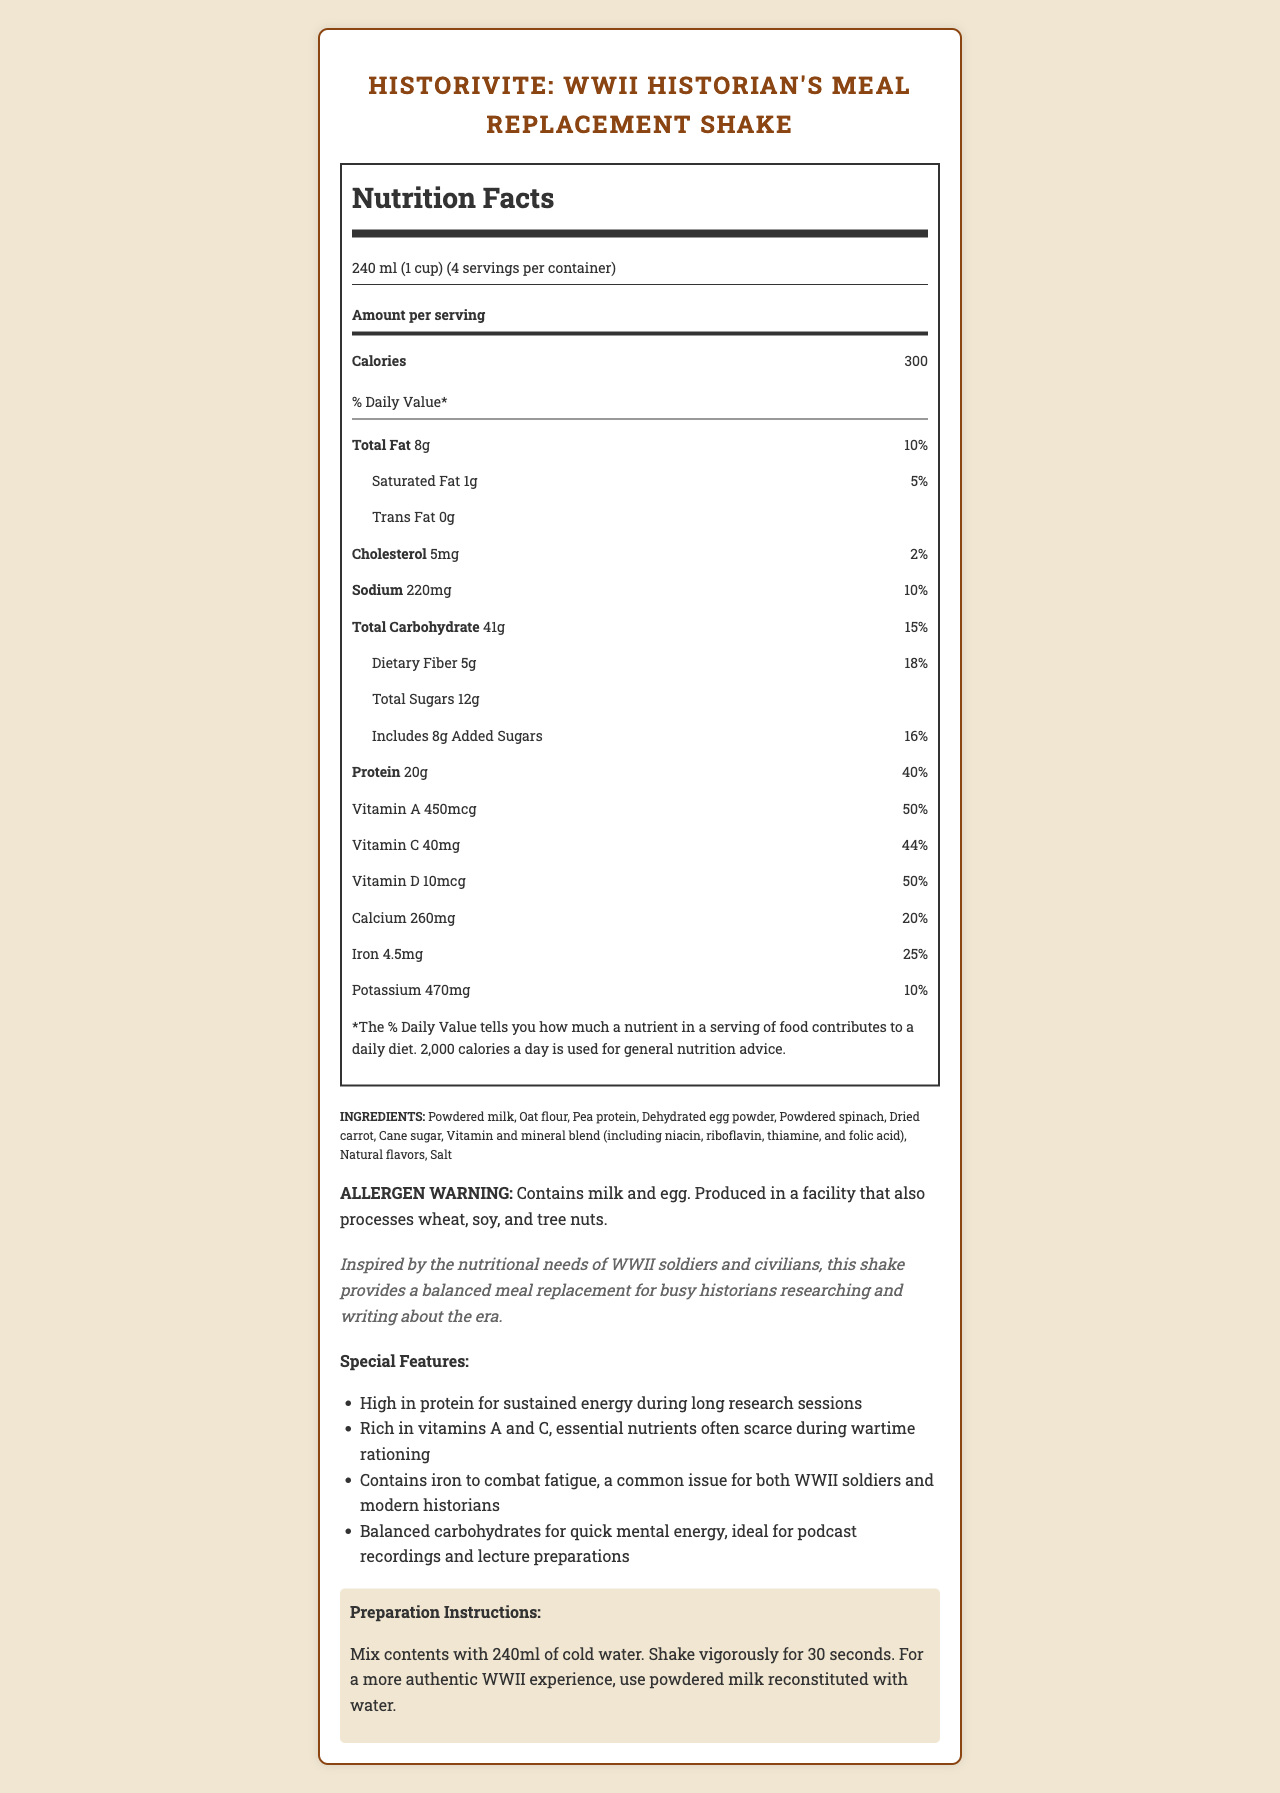what is the serving size of the meal replacement shake? The serving size is explicitly mentioned under the nutrition facts as "240 ml (1 cup)."
Answer: 240 ml (1 cup) how many calories are in one serving of HistoriVite? The document specifies that each serving contains 300 calories.
Answer: 300 list three ingredients found in HistoriVite? The ingredients list includes powdered milk, oat flour, and pea protein among others.
Answer: Powdered milk, Oat flour, Pea protein how many grams of dietary fiber are in each serving? The nutrition facts label states that there are 5 grams of dietary fiber per serving.
Answer: 5g what is the percent daily value of protein in one serving? The percent daily value of protein is indicated as 40% in the nutrition facts.
Answer: 40% how many servings are in one container of HistoriVite? The document specifies that there are 4 servings per container.
Answer: 4 how much sodium is in a serving of the shake? A. 100mg B. 150mg C. 220mg D. 300mg According to the nutrition facts, each serving contains 220 mg of sodium.
Answer: C which of the following vitamins is present in the highest percent daily value? A. Vitamin A B. Vitamin C C. Vitamin D D. Calcium Vitamin A has a percent daily value of 50%, which is the highest among the listed options.
Answer: A does the HistoriVite shake contain any trans fat? The nutrition facts clearly indicate that the shake contains 0g of trans fat.
Answer: No is HistoriVite suitable for individuals with egg allergies? The allergen warning specifies that the product contains egg.
Answer: No summarize the main purpose of the HistoriVite meal replacement shake. The shake aims to support historians by offering a convenient and nutritionally balanced option that mirrors the dietary needs of WWII-era individuals, but tailored for modern historians' hectic schedules.
Answer: The HistoriVite shake is designed as a balanced meal replacement for busy historians, inspired by the nutritional needs of WWII soldiers and civilians. It provides high protein for energy, essential vitamins, and iron to combat fatigue, making it ideal for long research sessions and lecture preparations. why was HistoriVite inspired by the nutritional needs of WWII soldiers and civilians? The historical context section states that the shake is inspired by the nutritional needs of WWII soldiers and civilians to aid historians focused on that era.
Answer: To provide a historically themed, balanced meal replacement that helps busy historians research and write about WWII. what is the total carbohydrate content in one serving? The nutrition facts label states that each serving contains 41 grams of total carbohydrates.
Answer: 41g how should HistoriVite be prepared for a more authentic WWII experience? The preparation instructions suggest using powdered milk reconstituted with water for a more authentic WWII experience.
Answer: Use powdered milk reconstituted with water. what are the special features of HistoriVite? The special features list includes high protein content, richness in vitamins A and C, presence of iron, and balanced carbohydrates for quick mental energy.
Answer: High in protein, rich in vitamins A and C, contains iron, balanced carbohydrates were rationing rules during WWII different between the Allied and Axis powers? The document does not provide details about rationing rules during WWII between the Allied and Axis powers.
Answer: Not enough information 